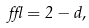<formula> <loc_0><loc_0><loc_500><loc_500>\epsilon = 2 - d ,</formula> 